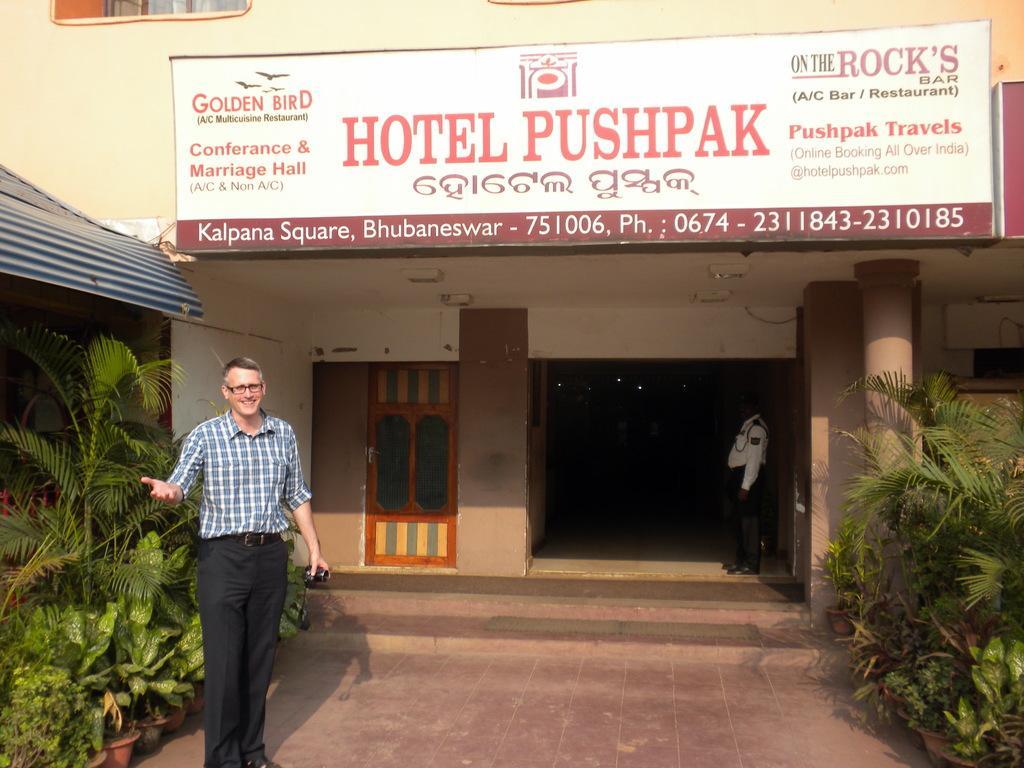Describe this image in one or two sentences. In this image, we can see a few people. There are a few plants. We can also see the window and an entrance. There are a few stairs. We can also see the ground. There is a board with some text printed. There is a shed on the left. We can see a pillar and some lights on the roof. 